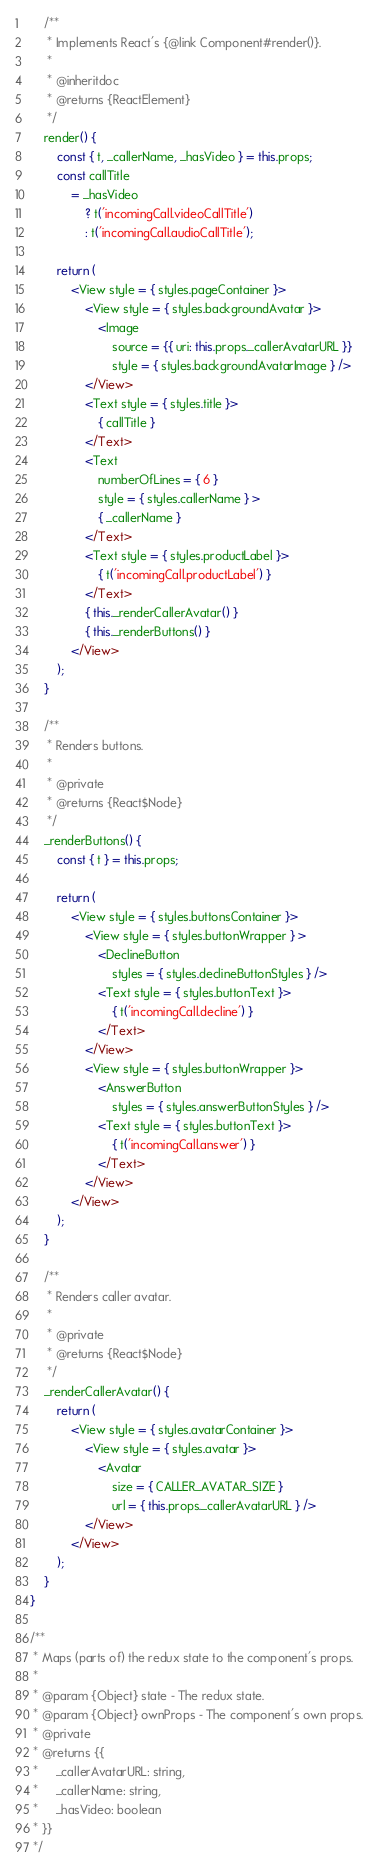Convert code to text. <code><loc_0><loc_0><loc_500><loc_500><_JavaScript_>    /**
     * Implements React's {@link Component#render()}.
     *
     * @inheritdoc
     * @returns {ReactElement}
     */
    render() {
        const { t, _callerName, _hasVideo } = this.props;
        const callTitle
            = _hasVideo
                ? t('incomingCall.videoCallTitle')
                : t('incomingCall.audioCallTitle');

        return (
            <View style = { styles.pageContainer }>
                <View style = { styles.backgroundAvatar }>
                    <Image
                        source = {{ uri: this.props._callerAvatarURL }}
                        style = { styles.backgroundAvatarImage } />
                </View>
                <Text style = { styles.title }>
                    { callTitle }
                </Text>
                <Text
                    numberOfLines = { 6 }
                    style = { styles.callerName } >
                    { _callerName }
                </Text>
                <Text style = { styles.productLabel }>
                    { t('incomingCall.productLabel') }
                </Text>
                { this._renderCallerAvatar() }
                { this._renderButtons() }
            </View>
        );
    }

    /**
     * Renders buttons.
     *
     * @private
     * @returns {React$Node}
     */
    _renderButtons() {
        const { t } = this.props;

        return (
            <View style = { styles.buttonsContainer }>
                <View style = { styles.buttonWrapper } >
                    <DeclineButton
                        styles = { styles.declineButtonStyles } />
                    <Text style = { styles.buttonText }>
                        { t('incomingCall.decline') }
                    </Text>
                </View>
                <View style = { styles.buttonWrapper }>
                    <AnswerButton
                        styles = { styles.answerButtonStyles } />
                    <Text style = { styles.buttonText }>
                        { t('incomingCall.answer') }
                    </Text>
                </View>
            </View>
        );
    }

    /**
     * Renders caller avatar.
     *
     * @private
     * @returns {React$Node}
     */
    _renderCallerAvatar() {
        return (
            <View style = { styles.avatarContainer }>
                <View style = { styles.avatar }>
                    <Avatar
                        size = { CALLER_AVATAR_SIZE }
                        url = { this.props._callerAvatarURL } />
                </View>
            </View>
        );
    }
}

/**
 * Maps (parts of) the redux state to the component's props.
 *
 * @param {Object} state - The redux state.
 * @param {Object} ownProps - The component's own props.
 * @private
 * @returns {{
 *     _callerAvatarURL: string,
 *     _callerName: string,
 *     _hasVideo: boolean
 * }}
 */</code> 